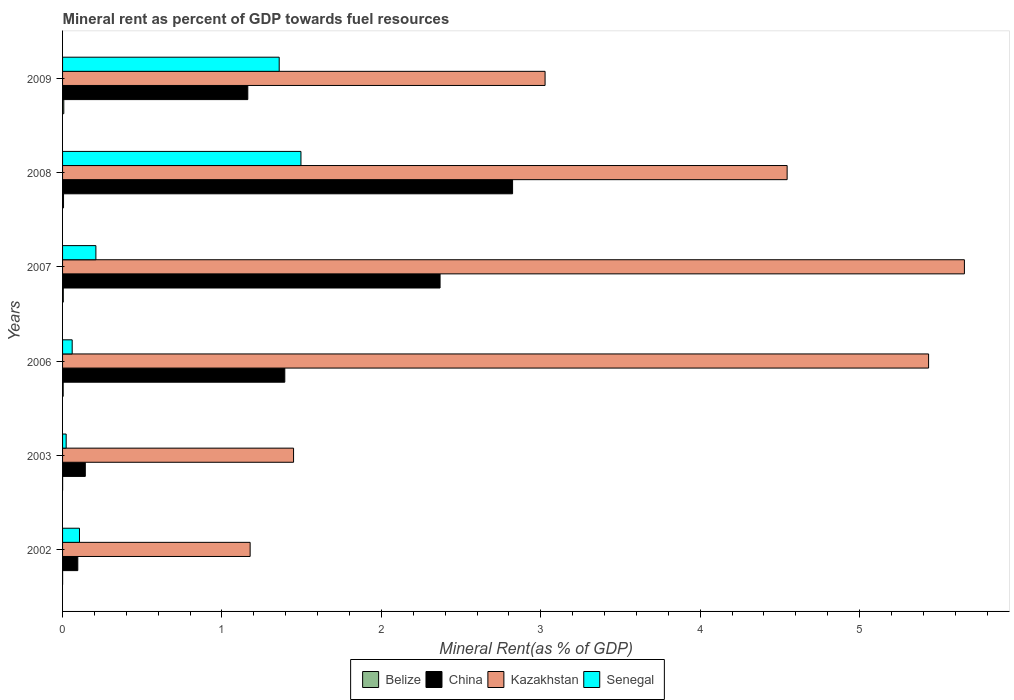How many different coloured bars are there?
Your answer should be compact. 4. Are the number of bars on each tick of the Y-axis equal?
Give a very brief answer. Yes. In how many cases, is the number of bars for a given year not equal to the number of legend labels?
Provide a succinct answer. 0. What is the mineral rent in Belize in 2002?
Keep it short and to the point. 0. Across all years, what is the maximum mineral rent in China?
Your answer should be compact. 2.82. Across all years, what is the minimum mineral rent in Kazakhstan?
Make the answer very short. 1.18. In which year was the mineral rent in China maximum?
Keep it short and to the point. 2008. In which year was the mineral rent in Kazakhstan minimum?
Offer a very short reply. 2002. What is the total mineral rent in Belize in the graph?
Provide a short and direct response. 0.02. What is the difference between the mineral rent in China in 2002 and that in 2003?
Provide a short and direct response. -0.05. What is the difference between the mineral rent in Senegal in 2003 and the mineral rent in Belize in 2002?
Your response must be concise. 0.02. What is the average mineral rent in China per year?
Your answer should be very brief. 1.33. In the year 2007, what is the difference between the mineral rent in Belize and mineral rent in China?
Offer a very short reply. -2.36. What is the ratio of the mineral rent in China in 2003 to that in 2006?
Provide a short and direct response. 0.1. Is the mineral rent in Belize in 2003 less than that in 2007?
Give a very brief answer. Yes. Is the difference between the mineral rent in Belize in 2003 and 2009 greater than the difference between the mineral rent in China in 2003 and 2009?
Give a very brief answer. Yes. What is the difference between the highest and the second highest mineral rent in China?
Offer a terse response. 0.45. What is the difference between the highest and the lowest mineral rent in China?
Provide a short and direct response. 2.73. Is it the case that in every year, the sum of the mineral rent in China and mineral rent in Senegal is greater than the sum of mineral rent in Belize and mineral rent in Kazakhstan?
Keep it short and to the point. No. What does the 3rd bar from the top in 2008 represents?
Your response must be concise. China. What does the 2nd bar from the bottom in 2007 represents?
Your response must be concise. China. What is the difference between two consecutive major ticks on the X-axis?
Offer a terse response. 1. Are the values on the major ticks of X-axis written in scientific E-notation?
Your response must be concise. No. Does the graph contain grids?
Offer a very short reply. No. How are the legend labels stacked?
Offer a very short reply. Horizontal. What is the title of the graph?
Provide a short and direct response. Mineral rent as percent of GDP towards fuel resources. Does "China" appear as one of the legend labels in the graph?
Provide a short and direct response. Yes. What is the label or title of the X-axis?
Your answer should be very brief. Mineral Rent(as % of GDP). What is the Mineral Rent(as % of GDP) in Belize in 2002?
Your answer should be compact. 0. What is the Mineral Rent(as % of GDP) in China in 2002?
Provide a short and direct response. 0.1. What is the Mineral Rent(as % of GDP) in Kazakhstan in 2002?
Offer a very short reply. 1.18. What is the Mineral Rent(as % of GDP) in Senegal in 2002?
Offer a very short reply. 0.11. What is the Mineral Rent(as % of GDP) in Belize in 2003?
Your answer should be compact. 0. What is the Mineral Rent(as % of GDP) in China in 2003?
Offer a very short reply. 0.14. What is the Mineral Rent(as % of GDP) in Kazakhstan in 2003?
Keep it short and to the point. 1.45. What is the Mineral Rent(as % of GDP) of Senegal in 2003?
Ensure brevity in your answer.  0.02. What is the Mineral Rent(as % of GDP) in Belize in 2006?
Provide a short and direct response. 0. What is the Mineral Rent(as % of GDP) in China in 2006?
Provide a short and direct response. 1.39. What is the Mineral Rent(as % of GDP) of Kazakhstan in 2006?
Keep it short and to the point. 5.43. What is the Mineral Rent(as % of GDP) in Senegal in 2006?
Offer a very short reply. 0.06. What is the Mineral Rent(as % of GDP) in Belize in 2007?
Offer a very short reply. 0. What is the Mineral Rent(as % of GDP) in China in 2007?
Offer a terse response. 2.37. What is the Mineral Rent(as % of GDP) in Kazakhstan in 2007?
Make the answer very short. 5.66. What is the Mineral Rent(as % of GDP) in Senegal in 2007?
Keep it short and to the point. 0.21. What is the Mineral Rent(as % of GDP) of Belize in 2008?
Keep it short and to the point. 0.01. What is the Mineral Rent(as % of GDP) in China in 2008?
Keep it short and to the point. 2.82. What is the Mineral Rent(as % of GDP) in Kazakhstan in 2008?
Your answer should be compact. 4.55. What is the Mineral Rent(as % of GDP) in Senegal in 2008?
Your answer should be compact. 1.5. What is the Mineral Rent(as % of GDP) in Belize in 2009?
Offer a terse response. 0.01. What is the Mineral Rent(as % of GDP) of China in 2009?
Offer a very short reply. 1.16. What is the Mineral Rent(as % of GDP) of Kazakhstan in 2009?
Make the answer very short. 3.03. What is the Mineral Rent(as % of GDP) of Senegal in 2009?
Offer a very short reply. 1.36. Across all years, what is the maximum Mineral Rent(as % of GDP) of Belize?
Make the answer very short. 0.01. Across all years, what is the maximum Mineral Rent(as % of GDP) of China?
Give a very brief answer. 2.82. Across all years, what is the maximum Mineral Rent(as % of GDP) in Kazakhstan?
Offer a very short reply. 5.66. Across all years, what is the maximum Mineral Rent(as % of GDP) in Senegal?
Give a very brief answer. 1.5. Across all years, what is the minimum Mineral Rent(as % of GDP) of Belize?
Give a very brief answer. 0. Across all years, what is the minimum Mineral Rent(as % of GDP) in China?
Provide a short and direct response. 0.1. Across all years, what is the minimum Mineral Rent(as % of GDP) of Kazakhstan?
Offer a very short reply. 1.18. Across all years, what is the minimum Mineral Rent(as % of GDP) of Senegal?
Provide a short and direct response. 0.02. What is the total Mineral Rent(as % of GDP) in Belize in the graph?
Ensure brevity in your answer.  0.02. What is the total Mineral Rent(as % of GDP) in China in the graph?
Give a very brief answer. 7.99. What is the total Mineral Rent(as % of GDP) of Kazakhstan in the graph?
Make the answer very short. 21.29. What is the total Mineral Rent(as % of GDP) in Senegal in the graph?
Provide a succinct answer. 3.25. What is the difference between the Mineral Rent(as % of GDP) in Belize in 2002 and that in 2003?
Your answer should be compact. -0. What is the difference between the Mineral Rent(as % of GDP) in China in 2002 and that in 2003?
Keep it short and to the point. -0.05. What is the difference between the Mineral Rent(as % of GDP) in Kazakhstan in 2002 and that in 2003?
Give a very brief answer. -0.27. What is the difference between the Mineral Rent(as % of GDP) of Senegal in 2002 and that in 2003?
Your answer should be very brief. 0.08. What is the difference between the Mineral Rent(as % of GDP) in Belize in 2002 and that in 2006?
Ensure brevity in your answer.  -0. What is the difference between the Mineral Rent(as % of GDP) in China in 2002 and that in 2006?
Ensure brevity in your answer.  -1.3. What is the difference between the Mineral Rent(as % of GDP) in Kazakhstan in 2002 and that in 2006?
Give a very brief answer. -4.26. What is the difference between the Mineral Rent(as % of GDP) of Senegal in 2002 and that in 2006?
Your answer should be compact. 0.05. What is the difference between the Mineral Rent(as % of GDP) of Belize in 2002 and that in 2007?
Make the answer very short. -0. What is the difference between the Mineral Rent(as % of GDP) in China in 2002 and that in 2007?
Offer a very short reply. -2.27. What is the difference between the Mineral Rent(as % of GDP) in Kazakhstan in 2002 and that in 2007?
Offer a very short reply. -4.48. What is the difference between the Mineral Rent(as % of GDP) in Senegal in 2002 and that in 2007?
Offer a terse response. -0.1. What is the difference between the Mineral Rent(as % of GDP) of Belize in 2002 and that in 2008?
Offer a very short reply. -0.01. What is the difference between the Mineral Rent(as % of GDP) of China in 2002 and that in 2008?
Keep it short and to the point. -2.73. What is the difference between the Mineral Rent(as % of GDP) in Kazakhstan in 2002 and that in 2008?
Provide a short and direct response. -3.37. What is the difference between the Mineral Rent(as % of GDP) in Senegal in 2002 and that in 2008?
Give a very brief answer. -1.39. What is the difference between the Mineral Rent(as % of GDP) of Belize in 2002 and that in 2009?
Your answer should be very brief. -0.01. What is the difference between the Mineral Rent(as % of GDP) of China in 2002 and that in 2009?
Ensure brevity in your answer.  -1.07. What is the difference between the Mineral Rent(as % of GDP) of Kazakhstan in 2002 and that in 2009?
Give a very brief answer. -1.85. What is the difference between the Mineral Rent(as % of GDP) in Senegal in 2002 and that in 2009?
Provide a succinct answer. -1.25. What is the difference between the Mineral Rent(as % of GDP) of Belize in 2003 and that in 2006?
Your answer should be compact. -0. What is the difference between the Mineral Rent(as % of GDP) of China in 2003 and that in 2006?
Ensure brevity in your answer.  -1.25. What is the difference between the Mineral Rent(as % of GDP) in Kazakhstan in 2003 and that in 2006?
Ensure brevity in your answer.  -3.98. What is the difference between the Mineral Rent(as % of GDP) in Senegal in 2003 and that in 2006?
Offer a terse response. -0.04. What is the difference between the Mineral Rent(as % of GDP) of Belize in 2003 and that in 2007?
Provide a short and direct response. -0. What is the difference between the Mineral Rent(as % of GDP) in China in 2003 and that in 2007?
Make the answer very short. -2.23. What is the difference between the Mineral Rent(as % of GDP) of Kazakhstan in 2003 and that in 2007?
Your answer should be very brief. -4.21. What is the difference between the Mineral Rent(as % of GDP) of Senegal in 2003 and that in 2007?
Give a very brief answer. -0.19. What is the difference between the Mineral Rent(as % of GDP) in Belize in 2003 and that in 2008?
Make the answer very short. -0.01. What is the difference between the Mineral Rent(as % of GDP) in China in 2003 and that in 2008?
Provide a short and direct response. -2.68. What is the difference between the Mineral Rent(as % of GDP) of Kazakhstan in 2003 and that in 2008?
Keep it short and to the point. -3.1. What is the difference between the Mineral Rent(as % of GDP) of Senegal in 2003 and that in 2008?
Keep it short and to the point. -1.47. What is the difference between the Mineral Rent(as % of GDP) in Belize in 2003 and that in 2009?
Your answer should be compact. -0.01. What is the difference between the Mineral Rent(as % of GDP) in China in 2003 and that in 2009?
Give a very brief answer. -1.02. What is the difference between the Mineral Rent(as % of GDP) of Kazakhstan in 2003 and that in 2009?
Your answer should be compact. -1.58. What is the difference between the Mineral Rent(as % of GDP) in Senegal in 2003 and that in 2009?
Keep it short and to the point. -1.34. What is the difference between the Mineral Rent(as % of GDP) in Belize in 2006 and that in 2007?
Your answer should be very brief. -0. What is the difference between the Mineral Rent(as % of GDP) in China in 2006 and that in 2007?
Provide a short and direct response. -0.97. What is the difference between the Mineral Rent(as % of GDP) in Kazakhstan in 2006 and that in 2007?
Ensure brevity in your answer.  -0.22. What is the difference between the Mineral Rent(as % of GDP) of Senegal in 2006 and that in 2007?
Your response must be concise. -0.15. What is the difference between the Mineral Rent(as % of GDP) in Belize in 2006 and that in 2008?
Provide a short and direct response. -0. What is the difference between the Mineral Rent(as % of GDP) in China in 2006 and that in 2008?
Your response must be concise. -1.43. What is the difference between the Mineral Rent(as % of GDP) in Kazakhstan in 2006 and that in 2008?
Offer a terse response. 0.89. What is the difference between the Mineral Rent(as % of GDP) of Senegal in 2006 and that in 2008?
Your answer should be compact. -1.44. What is the difference between the Mineral Rent(as % of GDP) in Belize in 2006 and that in 2009?
Provide a short and direct response. -0. What is the difference between the Mineral Rent(as % of GDP) in China in 2006 and that in 2009?
Offer a very short reply. 0.23. What is the difference between the Mineral Rent(as % of GDP) in Kazakhstan in 2006 and that in 2009?
Your response must be concise. 2.41. What is the difference between the Mineral Rent(as % of GDP) of Senegal in 2006 and that in 2009?
Make the answer very short. -1.3. What is the difference between the Mineral Rent(as % of GDP) of Belize in 2007 and that in 2008?
Your answer should be compact. -0. What is the difference between the Mineral Rent(as % of GDP) of China in 2007 and that in 2008?
Provide a succinct answer. -0.45. What is the difference between the Mineral Rent(as % of GDP) in Kazakhstan in 2007 and that in 2008?
Keep it short and to the point. 1.11. What is the difference between the Mineral Rent(as % of GDP) of Senegal in 2007 and that in 2008?
Provide a short and direct response. -1.29. What is the difference between the Mineral Rent(as % of GDP) of Belize in 2007 and that in 2009?
Your answer should be compact. -0. What is the difference between the Mineral Rent(as % of GDP) in China in 2007 and that in 2009?
Make the answer very short. 1.21. What is the difference between the Mineral Rent(as % of GDP) in Kazakhstan in 2007 and that in 2009?
Provide a succinct answer. 2.63. What is the difference between the Mineral Rent(as % of GDP) of Senegal in 2007 and that in 2009?
Give a very brief answer. -1.15. What is the difference between the Mineral Rent(as % of GDP) of Belize in 2008 and that in 2009?
Offer a terse response. -0. What is the difference between the Mineral Rent(as % of GDP) of China in 2008 and that in 2009?
Provide a succinct answer. 1.66. What is the difference between the Mineral Rent(as % of GDP) in Kazakhstan in 2008 and that in 2009?
Your response must be concise. 1.52. What is the difference between the Mineral Rent(as % of GDP) in Senegal in 2008 and that in 2009?
Offer a terse response. 0.14. What is the difference between the Mineral Rent(as % of GDP) of Belize in 2002 and the Mineral Rent(as % of GDP) of China in 2003?
Make the answer very short. -0.14. What is the difference between the Mineral Rent(as % of GDP) of Belize in 2002 and the Mineral Rent(as % of GDP) of Kazakhstan in 2003?
Ensure brevity in your answer.  -1.45. What is the difference between the Mineral Rent(as % of GDP) of Belize in 2002 and the Mineral Rent(as % of GDP) of Senegal in 2003?
Keep it short and to the point. -0.02. What is the difference between the Mineral Rent(as % of GDP) in China in 2002 and the Mineral Rent(as % of GDP) in Kazakhstan in 2003?
Offer a terse response. -1.35. What is the difference between the Mineral Rent(as % of GDP) in China in 2002 and the Mineral Rent(as % of GDP) in Senegal in 2003?
Your answer should be compact. 0.07. What is the difference between the Mineral Rent(as % of GDP) of Kazakhstan in 2002 and the Mineral Rent(as % of GDP) of Senegal in 2003?
Your answer should be compact. 1.15. What is the difference between the Mineral Rent(as % of GDP) in Belize in 2002 and the Mineral Rent(as % of GDP) in China in 2006?
Offer a very short reply. -1.39. What is the difference between the Mineral Rent(as % of GDP) in Belize in 2002 and the Mineral Rent(as % of GDP) in Kazakhstan in 2006?
Provide a short and direct response. -5.43. What is the difference between the Mineral Rent(as % of GDP) of Belize in 2002 and the Mineral Rent(as % of GDP) of Senegal in 2006?
Provide a short and direct response. -0.06. What is the difference between the Mineral Rent(as % of GDP) in China in 2002 and the Mineral Rent(as % of GDP) in Kazakhstan in 2006?
Your answer should be very brief. -5.34. What is the difference between the Mineral Rent(as % of GDP) of China in 2002 and the Mineral Rent(as % of GDP) of Senegal in 2006?
Offer a very short reply. 0.04. What is the difference between the Mineral Rent(as % of GDP) of Kazakhstan in 2002 and the Mineral Rent(as % of GDP) of Senegal in 2006?
Make the answer very short. 1.12. What is the difference between the Mineral Rent(as % of GDP) in Belize in 2002 and the Mineral Rent(as % of GDP) in China in 2007?
Ensure brevity in your answer.  -2.37. What is the difference between the Mineral Rent(as % of GDP) of Belize in 2002 and the Mineral Rent(as % of GDP) of Kazakhstan in 2007?
Your answer should be compact. -5.66. What is the difference between the Mineral Rent(as % of GDP) in Belize in 2002 and the Mineral Rent(as % of GDP) in Senegal in 2007?
Provide a succinct answer. -0.21. What is the difference between the Mineral Rent(as % of GDP) in China in 2002 and the Mineral Rent(as % of GDP) in Kazakhstan in 2007?
Offer a very short reply. -5.56. What is the difference between the Mineral Rent(as % of GDP) in China in 2002 and the Mineral Rent(as % of GDP) in Senegal in 2007?
Offer a very short reply. -0.11. What is the difference between the Mineral Rent(as % of GDP) of Kazakhstan in 2002 and the Mineral Rent(as % of GDP) of Senegal in 2007?
Provide a short and direct response. 0.97. What is the difference between the Mineral Rent(as % of GDP) of Belize in 2002 and the Mineral Rent(as % of GDP) of China in 2008?
Make the answer very short. -2.82. What is the difference between the Mineral Rent(as % of GDP) of Belize in 2002 and the Mineral Rent(as % of GDP) of Kazakhstan in 2008?
Your answer should be compact. -4.55. What is the difference between the Mineral Rent(as % of GDP) of Belize in 2002 and the Mineral Rent(as % of GDP) of Senegal in 2008?
Provide a short and direct response. -1.5. What is the difference between the Mineral Rent(as % of GDP) of China in 2002 and the Mineral Rent(as % of GDP) of Kazakhstan in 2008?
Offer a very short reply. -4.45. What is the difference between the Mineral Rent(as % of GDP) in China in 2002 and the Mineral Rent(as % of GDP) in Senegal in 2008?
Give a very brief answer. -1.4. What is the difference between the Mineral Rent(as % of GDP) in Kazakhstan in 2002 and the Mineral Rent(as % of GDP) in Senegal in 2008?
Your answer should be compact. -0.32. What is the difference between the Mineral Rent(as % of GDP) of Belize in 2002 and the Mineral Rent(as % of GDP) of China in 2009?
Give a very brief answer. -1.16. What is the difference between the Mineral Rent(as % of GDP) of Belize in 2002 and the Mineral Rent(as % of GDP) of Kazakhstan in 2009?
Your response must be concise. -3.03. What is the difference between the Mineral Rent(as % of GDP) of Belize in 2002 and the Mineral Rent(as % of GDP) of Senegal in 2009?
Ensure brevity in your answer.  -1.36. What is the difference between the Mineral Rent(as % of GDP) in China in 2002 and the Mineral Rent(as % of GDP) in Kazakhstan in 2009?
Keep it short and to the point. -2.93. What is the difference between the Mineral Rent(as % of GDP) in China in 2002 and the Mineral Rent(as % of GDP) in Senegal in 2009?
Your response must be concise. -1.26. What is the difference between the Mineral Rent(as % of GDP) in Kazakhstan in 2002 and the Mineral Rent(as % of GDP) in Senegal in 2009?
Ensure brevity in your answer.  -0.18. What is the difference between the Mineral Rent(as % of GDP) of Belize in 2003 and the Mineral Rent(as % of GDP) of China in 2006?
Offer a very short reply. -1.39. What is the difference between the Mineral Rent(as % of GDP) in Belize in 2003 and the Mineral Rent(as % of GDP) in Kazakhstan in 2006?
Provide a succinct answer. -5.43. What is the difference between the Mineral Rent(as % of GDP) in Belize in 2003 and the Mineral Rent(as % of GDP) in Senegal in 2006?
Your answer should be compact. -0.06. What is the difference between the Mineral Rent(as % of GDP) in China in 2003 and the Mineral Rent(as % of GDP) in Kazakhstan in 2006?
Your answer should be very brief. -5.29. What is the difference between the Mineral Rent(as % of GDP) of China in 2003 and the Mineral Rent(as % of GDP) of Senegal in 2006?
Offer a terse response. 0.08. What is the difference between the Mineral Rent(as % of GDP) of Kazakhstan in 2003 and the Mineral Rent(as % of GDP) of Senegal in 2006?
Keep it short and to the point. 1.39. What is the difference between the Mineral Rent(as % of GDP) in Belize in 2003 and the Mineral Rent(as % of GDP) in China in 2007?
Ensure brevity in your answer.  -2.37. What is the difference between the Mineral Rent(as % of GDP) of Belize in 2003 and the Mineral Rent(as % of GDP) of Kazakhstan in 2007?
Give a very brief answer. -5.66. What is the difference between the Mineral Rent(as % of GDP) of Belize in 2003 and the Mineral Rent(as % of GDP) of Senegal in 2007?
Ensure brevity in your answer.  -0.21. What is the difference between the Mineral Rent(as % of GDP) in China in 2003 and the Mineral Rent(as % of GDP) in Kazakhstan in 2007?
Offer a very short reply. -5.51. What is the difference between the Mineral Rent(as % of GDP) in China in 2003 and the Mineral Rent(as % of GDP) in Senegal in 2007?
Offer a very short reply. -0.07. What is the difference between the Mineral Rent(as % of GDP) of Kazakhstan in 2003 and the Mineral Rent(as % of GDP) of Senegal in 2007?
Make the answer very short. 1.24. What is the difference between the Mineral Rent(as % of GDP) of Belize in 2003 and the Mineral Rent(as % of GDP) of China in 2008?
Your answer should be very brief. -2.82. What is the difference between the Mineral Rent(as % of GDP) in Belize in 2003 and the Mineral Rent(as % of GDP) in Kazakhstan in 2008?
Provide a succinct answer. -4.54. What is the difference between the Mineral Rent(as % of GDP) in Belize in 2003 and the Mineral Rent(as % of GDP) in Senegal in 2008?
Your answer should be compact. -1.5. What is the difference between the Mineral Rent(as % of GDP) of China in 2003 and the Mineral Rent(as % of GDP) of Kazakhstan in 2008?
Provide a short and direct response. -4.4. What is the difference between the Mineral Rent(as % of GDP) of China in 2003 and the Mineral Rent(as % of GDP) of Senegal in 2008?
Give a very brief answer. -1.35. What is the difference between the Mineral Rent(as % of GDP) in Kazakhstan in 2003 and the Mineral Rent(as % of GDP) in Senegal in 2008?
Keep it short and to the point. -0.05. What is the difference between the Mineral Rent(as % of GDP) of Belize in 2003 and the Mineral Rent(as % of GDP) of China in 2009?
Keep it short and to the point. -1.16. What is the difference between the Mineral Rent(as % of GDP) of Belize in 2003 and the Mineral Rent(as % of GDP) of Kazakhstan in 2009?
Offer a terse response. -3.03. What is the difference between the Mineral Rent(as % of GDP) in Belize in 2003 and the Mineral Rent(as % of GDP) in Senegal in 2009?
Your response must be concise. -1.36. What is the difference between the Mineral Rent(as % of GDP) in China in 2003 and the Mineral Rent(as % of GDP) in Kazakhstan in 2009?
Your answer should be compact. -2.88. What is the difference between the Mineral Rent(as % of GDP) in China in 2003 and the Mineral Rent(as % of GDP) in Senegal in 2009?
Make the answer very short. -1.22. What is the difference between the Mineral Rent(as % of GDP) in Kazakhstan in 2003 and the Mineral Rent(as % of GDP) in Senegal in 2009?
Keep it short and to the point. 0.09. What is the difference between the Mineral Rent(as % of GDP) of Belize in 2006 and the Mineral Rent(as % of GDP) of China in 2007?
Give a very brief answer. -2.36. What is the difference between the Mineral Rent(as % of GDP) in Belize in 2006 and the Mineral Rent(as % of GDP) in Kazakhstan in 2007?
Your answer should be compact. -5.65. What is the difference between the Mineral Rent(as % of GDP) in Belize in 2006 and the Mineral Rent(as % of GDP) in Senegal in 2007?
Provide a succinct answer. -0.21. What is the difference between the Mineral Rent(as % of GDP) of China in 2006 and the Mineral Rent(as % of GDP) of Kazakhstan in 2007?
Ensure brevity in your answer.  -4.26. What is the difference between the Mineral Rent(as % of GDP) in China in 2006 and the Mineral Rent(as % of GDP) in Senegal in 2007?
Provide a short and direct response. 1.19. What is the difference between the Mineral Rent(as % of GDP) in Kazakhstan in 2006 and the Mineral Rent(as % of GDP) in Senegal in 2007?
Ensure brevity in your answer.  5.22. What is the difference between the Mineral Rent(as % of GDP) in Belize in 2006 and the Mineral Rent(as % of GDP) in China in 2008?
Offer a very short reply. -2.82. What is the difference between the Mineral Rent(as % of GDP) in Belize in 2006 and the Mineral Rent(as % of GDP) in Kazakhstan in 2008?
Provide a succinct answer. -4.54. What is the difference between the Mineral Rent(as % of GDP) of Belize in 2006 and the Mineral Rent(as % of GDP) of Senegal in 2008?
Make the answer very short. -1.49. What is the difference between the Mineral Rent(as % of GDP) in China in 2006 and the Mineral Rent(as % of GDP) in Kazakhstan in 2008?
Your response must be concise. -3.15. What is the difference between the Mineral Rent(as % of GDP) in China in 2006 and the Mineral Rent(as % of GDP) in Senegal in 2008?
Make the answer very short. -0.1. What is the difference between the Mineral Rent(as % of GDP) of Kazakhstan in 2006 and the Mineral Rent(as % of GDP) of Senegal in 2008?
Keep it short and to the point. 3.94. What is the difference between the Mineral Rent(as % of GDP) in Belize in 2006 and the Mineral Rent(as % of GDP) in China in 2009?
Provide a succinct answer. -1.16. What is the difference between the Mineral Rent(as % of GDP) in Belize in 2006 and the Mineral Rent(as % of GDP) in Kazakhstan in 2009?
Your response must be concise. -3.02. What is the difference between the Mineral Rent(as % of GDP) of Belize in 2006 and the Mineral Rent(as % of GDP) of Senegal in 2009?
Ensure brevity in your answer.  -1.36. What is the difference between the Mineral Rent(as % of GDP) of China in 2006 and the Mineral Rent(as % of GDP) of Kazakhstan in 2009?
Your answer should be very brief. -1.63. What is the difference between the Mineral Rent(as % of GDP) of China in 2006 and the Mineral Rent(as % of GDP) of Senegal in 2009?
Offer a terse response. 0.04. What is the difference between the Mineral Rent(as % of GDP) of Kazakhstan in 2006 and the Mineral Rent(as % of GDP) of Senegal in 2009?
Ensure brevity in your answer.  4.07. What is the difference between the Mineral Rent(as % of GDP) of Belize in 2007 and the Mineral Rent(as % of GDP) of China in 2008?
Keep it short and to the point. -2.82. What is the difference between the Mineral Rent(as % of GDP) in Belize in 2007 and the Mineral Rent(as % of GDP) in Kazakhstan in 2008?
Offer a very short reply. -4.54. What is the difference between the Mineral Rent(as % of GDP) of Belize in 2007 and the Mineral Rent(as % of GDP) of Senegal in 2008?
Ensure brevity in your answer.  -1.49. What is the difference between the Mineral Rent(as % of GDP) in China in 2007 and the Mineral Rent(as % of GDP) in Kazakhstan in 2008?
Provide a succinct answer. -2.18. What is the difference between the Mineral Rent(as % of GDP) in China in 2007 and the Mineral Rent(as % of GDP) in Senegal in 2008?
Give a very brief answer. 0.87. What is the difference between the Mineral Rent(as % of GDP) of Kazakhstan in 2007 and the Mineral Rent(as % of GDP) of Senegal in 2008?
Your response must be concise. 4.16. What is the difference between the Mineral Rent(as % of GDP) of Belize in 2007 and the Mineral Rent(as % of GDP) of China in 2009?
Your answer should be very brief. -1.16. What is the difference between the Mineral Rent(as % of GDP) in Belize in 2007 and the Mineral Rent(as % of GDP) in Kazakhstan in 2009?
Offer a terse response. -3.02. What is the difference between the Mineral Rent(as % of GDP) of Belize in 2007 and the Mineral Rent(as % of GDP) of Senegal in 2009?
Your response must be concise. -1.35. What is the difference between the Mineral Rent(as % of GDP) of China in 2007 and the Mineral Rent(as % of GDP) of Kazakhstan in 2009?
Your answer should be very brief. -0.66. What is the difference between the Mineral Rent(as % of GDP) in China in 2007 and the Mineral Rent(as % of GDP) in Senegal in 2009?
Your response must be concise. 1.01. What is the difference between the Mineral Rent(as % of GDP) of Kazakhstan in 2007 and the Mineral Rent(as % of GDP) of Senegal in 2009?
Provide a succinct answer. 4.3. What is the difference between the Mineral Rent(as % of GDP) in Belize in 2008 and the Mineral Rent(as % of GDP) in China in 2009?
Offer a terse response. -1.16. What is the difference between the Mineral Rent(as % of GDP) of Belize in 2008 and the Mineral Rent(as % of GDP) of Kazakhstan in 2009?
Offer a terse response. -3.02. What is the difference between the Mineral Rent(as % of GDP) in Belize in 2008 and the Mineral Rent(as % of GDP) in Senegal in 2009?
Keep it short and to the point. -1.35. What is the difference between the Mineral Rent(as % of GDP) in China in 2008 and the Mineral Rent(as % of GDP) in Kazakhstan in 2009?
Your response must be concise. -0.2. What is the difference between the Mineral Rent(as % of GDP) of China in 2008 and the Mineral Rent(as % of GDP) of Senegal in 2009?
Your response must be concise. 1.46. What is the difference between the Mineral Rent(as % of GDP) in Kazakhstan in 2008 and the Mineral Rent(as % of GDP) in Senegal in 2009?
Give a very brief answer. 3.19. What is the average Mineral Rent(as % of GDP) in Belize per year?
Provide a short and direct response. 0. What is the average Mineral Rent(as % of GDP) of China per year?
Provide a short and direct response. 1.33. What is the average Mineral Rent(as % of GDP) of Kazakhstan per year?
Offer a very short reply. 3.55. What is the average Mineral Rent(as % of GDP) of Senegal per year?
Your answer should be very brief. 0.54. In the year 2002, what is the difference between the Mineral Rent(as % of GDP) in Belize and Mineral Rent(as % of GDP) in China?
Offer a very short reply. -0.1. In the year 2002, what is the difference between the Mineral Rent(as % of GDP) of Belize and Mineral Rent(as % of GDP) of Kazakhstan?
Keep it short and to the point. -1.18. In the year 2002, what is the difference between the Mineral Rent(as % of GDP) of Belize and Mineral Rent(as % of GDP) of Senegal?
Your response must be concise. -0.11. In the year 2002, what is the difference between the Mineral Rent(as % of GDP) in China and Mineral Rent(as % of GDP) in Kazakhstan?
Offer a very short reply. -1.08. In the year 2002, what is the difference between the Mineral Rent(as % of GDP) of China and Mineral Rent(as % of GDP) of Senegal?
Offer a terse response. -0.01. In the year 2002, what is the difference between the Mineral Rent(as % of GDP) in Kazakhstan and Mineral Rent(as % of GDP) in Senegal?
Your answer should be very brief. 1.07. In the year 2003, what is the difference between the Mineral Rent(as % of GDP) in Belize and Mineral Rent(as % of GDP) in China?
Ensure brevity in your answer.  -0.14. In the year 2003, what is the difference between the Mineral Rent(as % of GDP) in Belize and Mineral Rent(as % of GDP) in Kazakhstan?
Provide a succinct answer. -1.45. In the year 2003, what is the difference between the Mineral Rent(as % of GDP) of Belize and Mineral Rent(as % of GDP) of Senegal?
Offer a very short reply. -0.02. In the year 2003, what is the difference between the Mineral Rent(as % of GDP) in China and Mineral Rent(as % of GDP) in Kazakhstan?
Provide a succinct answer. -1.31. In the year 2003, what is the difference between the Mineral Rent(as % of GDP) of China and Mineral Rent(as % of GDP) of Senegal?
Your response must be concise. 0.12. In the year 2003, what is the difference between the Mineral Rent(as % of GDP) of Kazakhstan and Mineral Rent(as % of GDP) of Senegal?
Provide a succinct answer. 1.43. In the year 2006, what is the difference between the Mineral Rent(as % of GDP) in Belize and Mineral Rent(as % of GDP) in China?
Offer a very short reply. -1.39. In the year 2006, what is the difference between the Mineral Rent(as % of GDP) of Belize and Mineral Rent(as % of GDP) of Kazakhstan?
Ensure brevity in your answer.  -5.43. In the year 2006, what is the difference between the Mineral Rent(as % of GDP) of Belize and Mineral Rent(as % of GDP) of Senegal?
Your response must be concise. -0.06. In the year 2006, what is the difference between the Mineral Rent(as % of GDP) of China and Mineral Rent(as % of GDP) of Kazakhstan?
Your answer should be compact. -4.04. In the year 2006, what is the difference between the Mineral Rent(as % of GDP) of China and Mineral Rent(as % of GDP) of Senegal?
Ensure brevity in your answer.  1.33. In the year 2006, what is the difference between the Mineral Rent(as % of GDP) of Kazakhstan and Mineral Rent(as % of GDP) of Senegal?
Keep it short and to the point. 5.37. In the year 2007, what is the difference between the Mineral Rent(as % of GDP) of Belize and Mineral Rent(as % of GDP) of China?
Provide a short and direct response. -2.36. In the year 2007, what is the difference between the Mineral Rent(as % of GDP) in Belize and Mineral Rent(as % of GDP) in Kazakhstan?
Provide a succinct answer. -5.65. In the year 2007, what is the difference between the Mineral Rent(as % of GDP) of Belize and Mineral Rent(as % of GDP) of Senegal?
Your answer should be very brief. -0.2. In the year 2007, what is the difference between the Mineral Rent(as % of GDP) of China and Mineral Rent(as % of GDP) of Kazakhstan?
Your answer should be compact. -3.29. In the year 2007, what is the difference between the Mineral Rent(as % of GDP) of China and Mineral Rent(as % of GDP) of Senegal?
Your answer should be compact. 2.16. In the year 2007, what is the difference between the Mineral Rent(as % of GDP) in Kazakhstan and Mineral Rent(as % of GDP) in Senegal?
Make the answer very short. 5.45. In the year 2008, what is the difference between the Mineral Rent(as % of GDP) in Belize and Mineral Rent(as % of GDP) in China?
Give a very brief answer. -2.82. In the year 2008, what is the difference between the Mineral Rent(as % of GDP) of Belize and Mineral Rent(as % of GDP) of Kazakhstan?
Keep it short and to the point. -4.54. In the year 2008, what is the difference between the Mineral Rent(as % of GDP) in Belize and Mineral Rent(as % of GDP) in Senegal?
Provide a succinct answer. -1.49. In the year 2008, what is the difference between the Mineral Rent(as % of GDP) in China and Mineral Rent(as % of GDP) in Kazakhstan?
Offer a terse response. -1.72. In the year 2008, what is the difference between the Mineral Rent(as % of GDP) of China and Mineral Rent(as % of GDP) of Senegal?
Offer a very short reply. 1.33. In the year 2008, what is the difference between the Mineral Rent(as % of GDP) of Kazakhstan and Mineral Rent(as % of GDP) of Senegal?
Your answer should be compact. 3.05. In the year 2009, what is the difference between the Mineral Rent(as % of GDP) in Belize and Mineral Rent(as % of GDP) in China?
Give a very brief answer. -1.15. In the year 2009, what is the difference between the Mineral Rent(as % of GDP) of Belize and Mineral Rent(as % of GDP) of Kazakhstan?
Make the answer very short. -3.02. In the year 2009, what is the difference between the Mineral Rent(as % of GDP) of Belize and Mineral Rent(as % of GDP) of Senegal?
Provide a succinct answer. -1.35. In the year 2009, what is the difference between the Mineral Rent(as % of GDP) in China and Mineral Rent(as % of GDP) in Kazakhstan?
Give a very brief answer. -1.86. In the year 2009, what is the difference between the Mineral Rent(as % of GDP) in China and Mineral Rent(as % of GDP) in Senegal?
Your response must be concise. -0.2. In the year 2009, what is the difference between the Mineral Rent(as % of GDP) in Kazakhstan and Mineral Rent(as % of GDP) in Senegal?
Give a very brief answer. 1.67. What is the ratio of the Mineral Rent(as % of GDP) in Belize in 2002 to that in 2003?
Make the answer very short. 0.58. What is the ratio of the Mineral Rent(as % of GDP) in China in 2002 to that in 2003?
Give a very brief answer. 0.67. What is the ratio of the Mineral Rent(as % of GDP) of Kazakhstan in 2002 to that in 2003?
Your response must be concise. 0.81. What is the ratio of the Mineral Rent(as % of GDP) of Senegal in 2002 to that in 2003?
Provide a short and direct response. 4.69. What is the ratio of the Mineral Rent(as % of GDP) of Belize in 2002 to that in 2006?
Provide a succinct answer. 0.04. What is the ratio of the Mineral Rent(as % of GDP) in China in 2002 to that in 2006?
Your answer should be compact. 0.07. What is the ratio of the Mineral Rent(as % of GDP) of Kazakhstan in 2002 to that in 2006?
Offer a very short reply. 0.22. What is the ratio of the Mineral Rent(as % of GDP) in Senegal in 2002 to that in 2006?
Keep it short and to the point. 1.76. What is the ratio of the Mineral Rent(as % of GDP) in Belize in 2002 to that in 2007?
Make the answer very short. 0.04. What is the ratio of the Mineral Rent(as % of GDP) in China in 2002 to that in 2007?
Your answer should be very brief. 0.04. What is the ratio of the Mineral Rent(as % of GDP) of Kazakhstan in 2002 to that in 2007?
Provide a short and direct response. 0.21. What is the ratio of the Mineral Rent(as % of GDP) in Senegal in 2002 to that in 2007?
Give a very brief answer. 0.51. What is the ratio of the Mineral Rent(as % of GDP) in Belize in 2002 to that in 2008?
Make the answer very short. 0.03. What is the ratio of the Mineral Rent(as % of GDP) of China in 2002 to that in 2008?
Your answer should be very brief. 0.03. What is the ratio of the Mineral Rent(as % of GDP) in Kazakhstan in 2002 to that in 2008?
Your answer should be compact. 0.26. What is the ratio of the Mineral Rent(as % of GDP) in Senegal in 2002 to that in 2008?
Offer a terse response. 0.07. What is the ratio of the Mineral Rent(as % of GDP) of Belize in 2002 to that in 2009?
Give a very brief answer. 0.02. What is the ratio of the Mineral Rent(as % of GDP) of China in 2002 to that in 2009?
Your answer should be very brief. 0.08. What is the ratio of the Mineral Rent(as % of GDP) in Kazakhstan in 2002 to that in 2009?
Offer a terse response. 0.39. What is the ratio of the Mineral Rent(as % of GDP) in Senegal in 2002 to that in 2009?
Your response must be concise. 0.08. What is the ratio of the Mineral Rent(as % of GDP) of Belize in 2003 to that in 2006?
Your answer should be compact. 0.07. What is the ratio of the Mineral Rent(as % of GDP) in China in 2003 to that in 2006?
Offer a terse response. 0.1. What is the ratio of the Mineral Rent(as % of GDP) in Kazakhstan in 2003 to that in 2006?
Provide a succinct answer. 0.27. What is the ratio of the Mineral Rent(as % of GDP) in Senegal in 2003 to that in 2006?
Your answer should be very brief. 0.37. What is the ratio of the Mineral Rent(as % of GDP) of Belize in 2003 to that in 2007?
Make the answer very short. 0.06. What is the ratio of the Mineral Rent(as % of GDP) in China in 2003 to that in 2007?
Keep it short and to the point. 0.06. What is the ratio of the Mineral Rent(as % of GDP) of Kazakhstan in 2003 to that in 2007?
Provide a succinct answer. 0.26. What is the ratio of the Mineral Rent(as % of GDP) in Senegal in 2003 to that in 2007?
Offer a very short reply. 0.11. What is the ratio of the Mineral Rent(as % of GDP) of Belize in 2003 to that in 2008?
Offer a very short reply. 0.05. What is the ratio of the Mineral Rent(as % of GDP) of China in 2003 to that in 2008?
Keep it short and to the point. 0.05. What is the ratio of the Mineral Rent(as % of GDP) of Kazakhstan in 2003 to that in 2008?
Keep it short and to the point. 0.32. What is the ratio of the Mineral Rent(as % of GDP) in Senegal in 2003 to that in 2008?
Offer a terse response. 0.02. What is the ratio of the Mineral Rent(as % of GDP) in Belize in 2003 to that in 2009?
Provide a short and direct response. 0.04. What is the ratio of the Mineral Rent(as % of GDP) of China in 2003 to that in 2009?
Ensure brevity in your answer.  0.12. What is the ratio of the Mineral Rent(as % of GDP) in Kazakhstan in 2003 to that in 2009?
Provide a short and direct response. 0.48. What is the ratio of the Mineral Rent(as % of GDP) of Senegal in 2003 to that in 2009?
Make the answer very short. 0.02. What is the ratio of the Mineral Rent(as % of GDP) in Belize in 2006 to that in 2007?
Your answer should be very brief. 0.85. What is the ratio of the Mineral Rent(as % of GDP) of China in 2006 to that in 2007?
Keep it short and to the point. 0.59. What is the ratio of the Mineral Rent(as % of GDP) in Kazakhstan in 2006 to that in 2007?
Provide a short and direct response. 0.96. What is the ratio of the Mineral Rent(as % of GDP) of Senegal in 2006 to that in 2007?
Ensure brevity in your answer.  0.29. What is the ratio of the Mineral Rent(as % of GDP) of Belize in 2006 to that in 2008?
Keep it short and to the point. 0.64. What is the ratio of the Mineral Rent(as % of GDP) of China in 2006 to that in 2008?
Your response must be concise. 0.49. What is the ratio of the Mineral Rent(as % of GDP) in Kazakhstan in 2006 to that in 2008?
Ensure brevity in your answer.  1.2. What is the ratio of the Mineral Rent(as % of GDP) of Senegal in 2006 to that in 2008?
Offer a very short reply. 0.04. What is the ratio of the Mineral Rent(as % of GDP) in Belize in 2006 to that in 2009?
Offer a very short reply. 0.5. What is the ratio of the Mineral Rent(as % of GDP) of China in 2006 to that in 2009?
Offer a terse response. 1.2. What is the ratio of the Mineral Rent(as % of GDP) of Kazakhstan in 2006 to that in 2009?
Keep it short and to the point. 1.79. What is the ratio of the Mineral Rent(as % of GDP) of Senegal in 2006 to that in 2009?
Keep it short and to the point. 0.04. What is the ratio of the Mineral Rent(as % of GDP) in Belize in 2007 to that in 2008?
Offer a very short reply. 0.75. What is the ratio of the Mineral Rent(as % of GDP) in China in 2007 to that in 2008?
Make the answer very short. 0.84. What is the ratio of the Mineral Rent(as % of GDP) in Kazakhstan in 2007 to that in 2008?
Keep it short and to the point. 1.24. What is the ratio of the Mineral Rent(as % of GDP) of Senegal in 2007 to that in 2008?
Provide a succinct answer. 0.14. What is the ratio of the Mineral Rent(as % of GDP) of Belize in 2007 to that in 2009?
Ensure brevity in your answer.  0.59. What is the ratio of the Mineral Rent(as % of GDP) in China in 2007 to that in 2009?
Give a very brief answer. 2.04. What is the ratio of the Mineral Rent(as % of GDP) of Kazakhstan in 2007 to that in 2009?
Provide a succinct answer. 1.87. What is the ratio of the Mineral Rent(as % of GDP) in Senegal in 2007 to that in 2009?
Provide a short and direct response. 0.15. What is the ratio of the Mineral Rent(as % of GDP) in Belize in 2008 to that in 2009?
Your response must be concise. 0.79. What is the ratio of the Mineral Rent(as % of GDP) in China in 2008 to that in 2009?
Provide a short and direct response. 2.43. What is the ratio of the Mineral Rent(as % of GDP) of Kazakhstan in 2008 to that in 2009?
Offer a very short reply. 1.5. What is the ratio of the Mineral Rent(as % of GDP) in Senegal in 2008 to that in 2009?
Ensure brevity in your answer.  1.1. What is the difference between the highest and the second highest Mineral Rent(as % of GDP) in Belize?
Provide a short and direct response. 0. What is the difference between the highest and the second highest Mineral Rent(as % of GDP) of China?
Offer a terse response. 0.45. What is the difference between the highest and the second highest Mineral Rent(as % of GDP) of Kazakhstan?
Keep it short and to the point. 0.22. What is the difference between the highest and the second highest Mineral Rent(as % of GDP) of Senegal?
Your answer should be very brief. 0.14. What is the difference between the highest and the lowest Mineral Rent(as % of GDP) of Belize?
Your answer should be very brief. 0.01. What is the difference between the highest and the lowest Mineral Rent(as % of GDP) in China?
Keep it short and to the point. 2.73. What is the difference between the highest and the lowest Mineral Rent(as % of GDP) in Kazakhstan?
Your answer should be compact. 4.48. What is the difference between the highest and the lowest Mineral Rent(as % of GDP) in Senegal?
Provide a succinct answer. 1.47. 